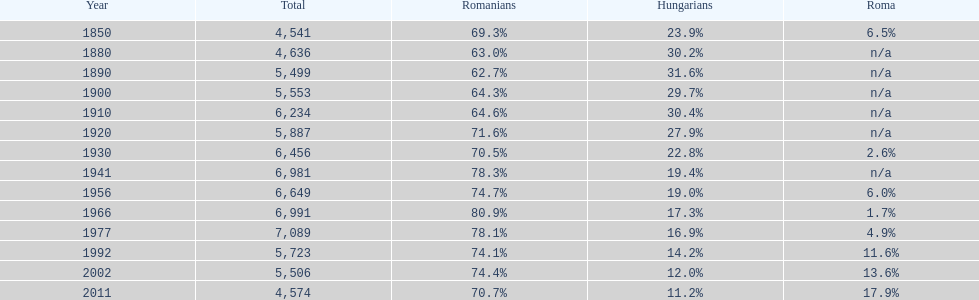4% hungarian individuals? 1941. 